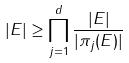Convert formula to latex. <formula><loc_0><loc_0><loc_500><loc_500>| E | \geq \prod _ { j = 1 } ^ { d } \frac { | E | } { | \pi _ { j } ( E ) | }</formula> 